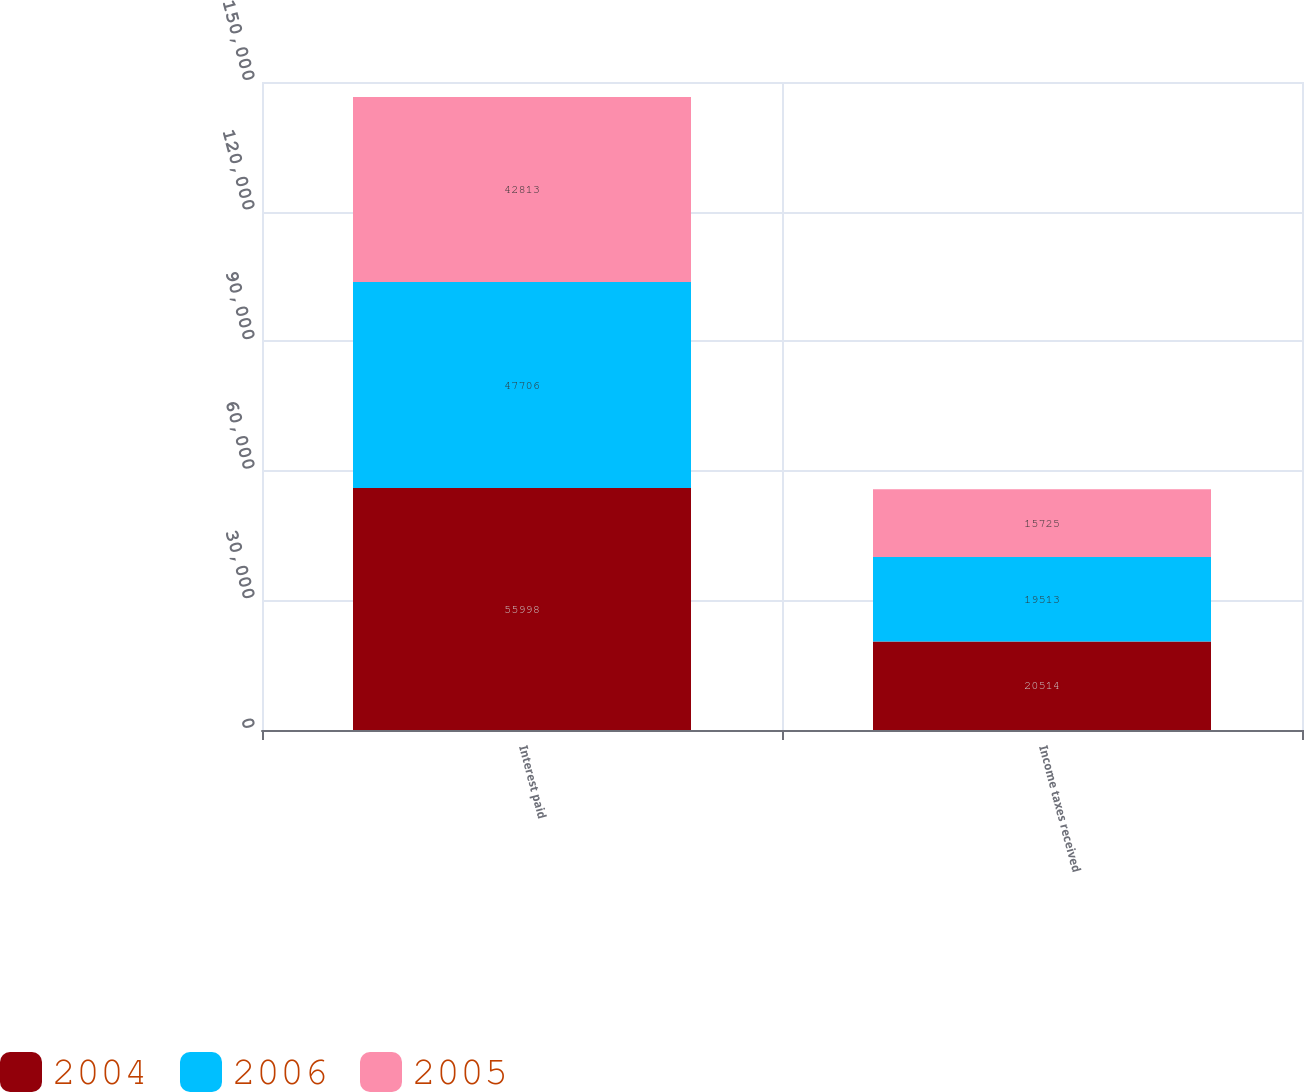Convert chart. <chart><loc_0><loc_0><loc_500><loc_500><stacked_bar_chart><ecel><fcel>Interest paid<fcel>Income taxes received<nl><fcel>2004<fcel>55998<fcel>20514<nl><fcel>2006<fcel>47706<fcel>19513<nl><fcel>2005<fcel>42813<fcel>15725<nl></chart> 